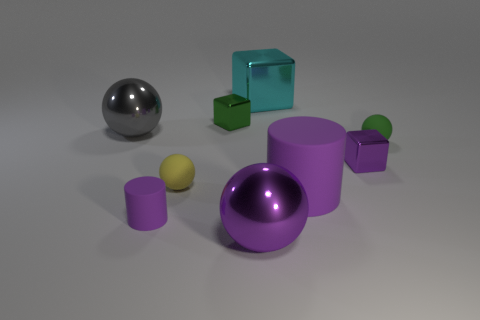Add 1 large gray things. How many objects exist? 10 Subtract all spheres. How many objects are left? 5 Subtract 0 cyan spheres. How many objects are left? 9 Subtract all yellow objects. Subtract all metal spheres. How many objects are left? 6 Add 6 tiny cylinders. How many tiny cylinders are left? 7 Add 8 small green matte spheres. How many small green matte spheres exist? 9 